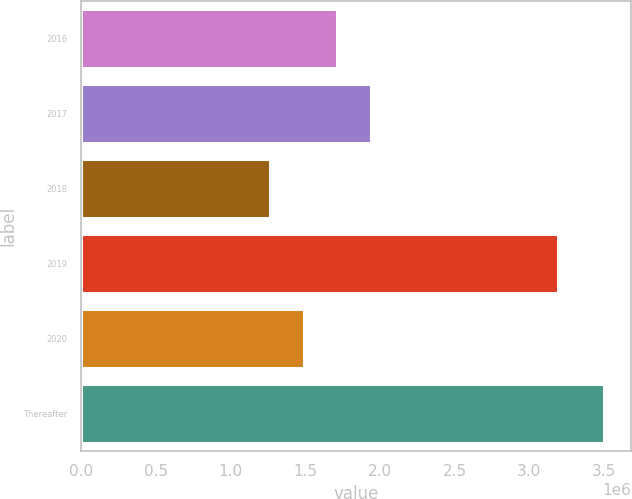<chart> <loc_0><loc_0><loc_500><loc_500><bar_chart><fcel>2016<fcel>2017<fcel>2018<fcel>2019<fcel>2020<fcel>Thereafter<nl><fcel>1.72324e+06<fcel>1.94647e+06<fcel>1.27245e+06<fcel>3.19696e+06<fcel>1.5e+06<fcel>3.50482e+06<nl></chart> 